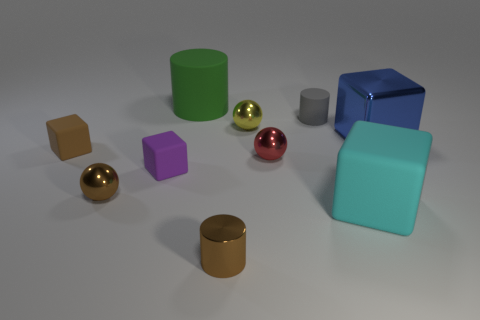Subtract all red cubes. Subtract all red cylinders. How many cubes are left? 4 Subtract all cylinders. How many objects are left? 7 Add 9 small blue metallic balls. How many small blue metallic balls exist? 9 Subtract 0 yellow cubes. How many objects are left? 10 Subtract all big blue spheres. Subtract all red spheres. How many objects are left? 9 Add 2 big rubber things. How many big rubber things are left? 4 